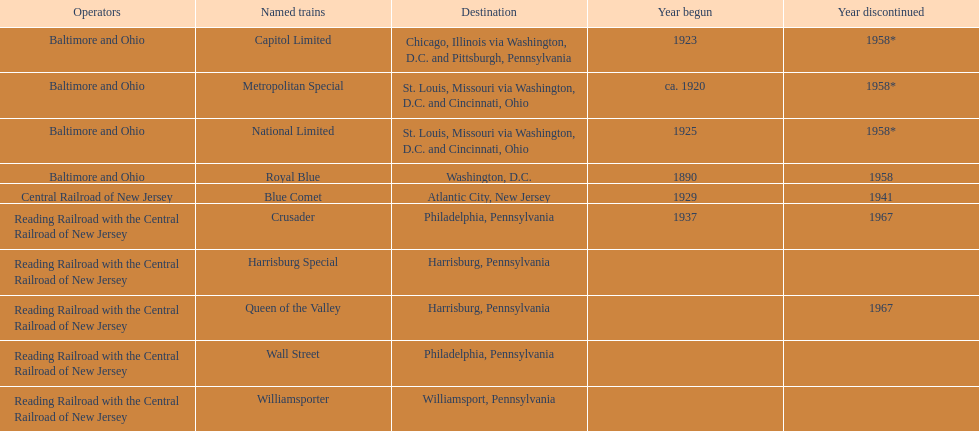Which train was in service for the greatest length of time? Royal Blue. 